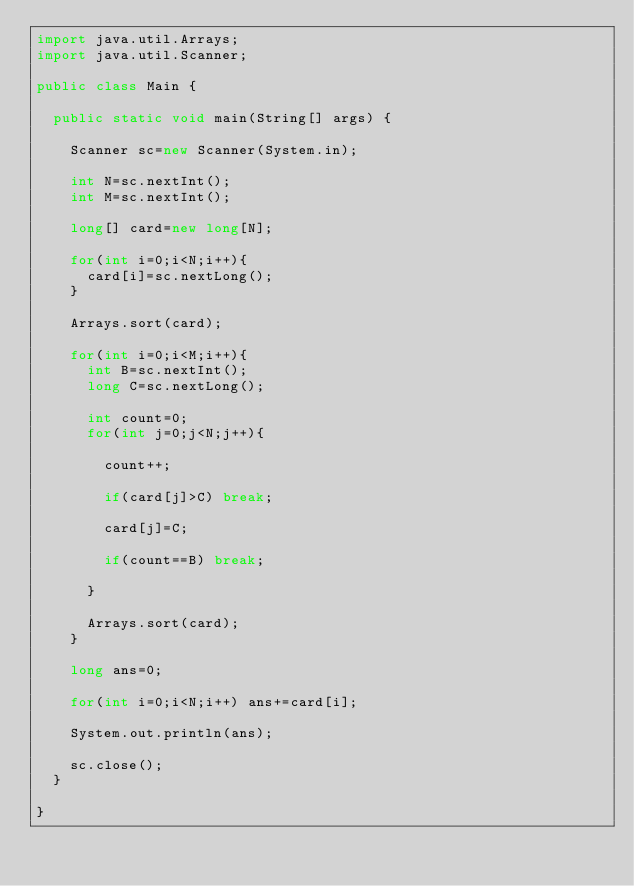Convert code to text. <code><loc_0><loc_0><loc_500><loc_500><_Java_>import java.util.Arrays;
import java.util.Scanner;
 
public class Main {
 
	public static void main(String[] args) {
 
		Scanner sc=new Scanner(System.in);
 
		int N=sc.nextInt();
		int M=sc.nextInt();
 
		long[] card=new long[N];
 
		for(int i=0;i<N;i++){
			card[i]=sc.nextLong();
		}
 
		Arrays.sort(card);
 
		for(int i=0;i<M;i++){
			int B=sc.nextInt();
			long C=sc.nextLong();
 
			int count=0;
			for(int j=0;j<N;j++){
 
				count++;
 
				if(card[j]>C) break;
 
				card[j]=C;
 
				if(count==B) break;
 
			}
 
			Arrays.sort(card);
		}
 
		long ans=0;
 
		for(int i=0;i<N;i++) ans+=card[i];
 
		System.out.println(ans);
 
		sc.close();
	}
 
}</code> 